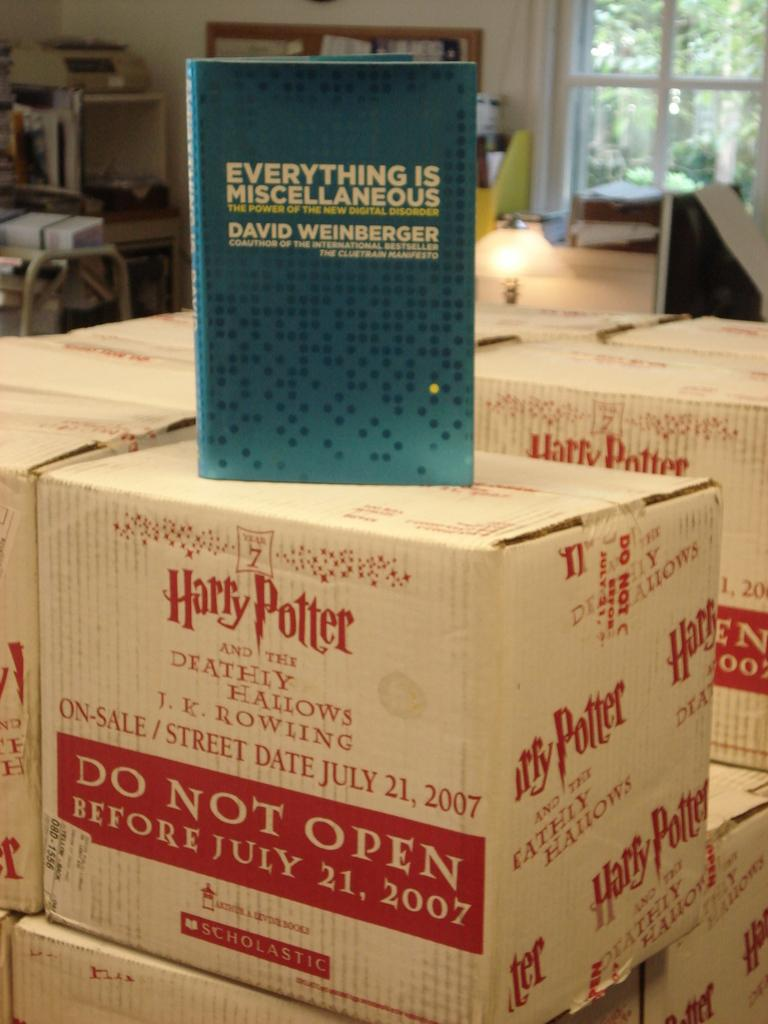Provide a one-sentence caption for the provided image. Stacks of white boxes containing the book Harry Potter and the Deathly Hallows. 